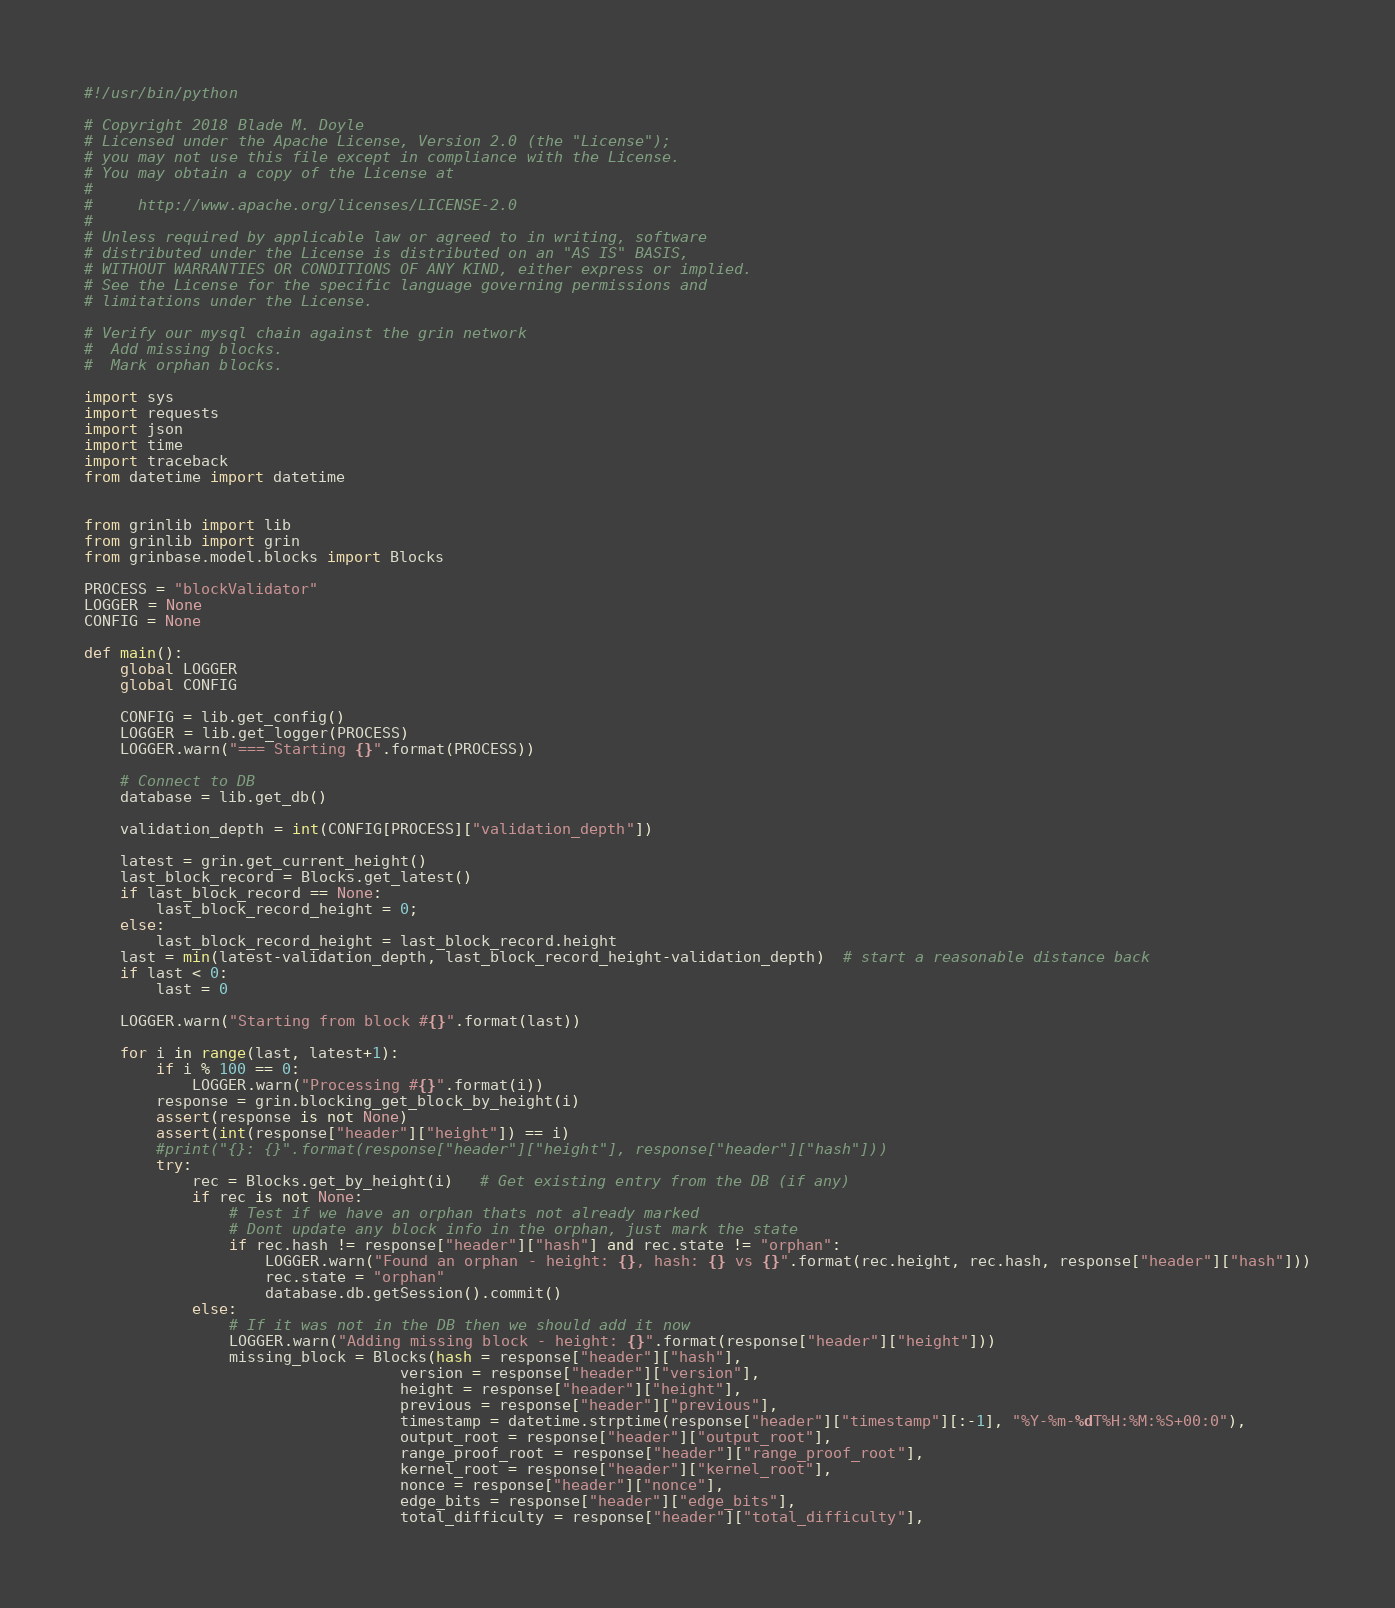<code> <loc_0><loc_0><loc_500><loc_500><_Python_>#!/usr/bin/python

# Copyright 2018 Blade M. Doyle
# Licensed under the Apache License, Version 2.0 (the "License");
# you may not use this file except in compliance with the License.
# You may obtain a copy of the License at
#
#     http://www.apache.org/licenses/LICENSE-2.0
#
# Unless required by applicable law or agreed to in writing, software
# distributed under the License is distributed on an "AS IS" BASIS,
# WITHOUT WARRANTIES OR CONDITIONS OF ANY KIND, either express or implied.
# See the License for the specific language governing permissions and
# limitations under the License.

# Verify our mysql chain against the grin network
#  Add missing blocks.
#  Mark orphan blocks.

import sys
import requests
import json
import time
import traceback
from datetime import datetime


from grinlib import lib
from grinlib import grin
from grinbase.model.blocks import Blocks

PROCESS = "blockValidator"
LOGGER = None
CONFIG = None

def main():
    global LOGGER
    global CONFIG

    CONFIG = lib.get_config()
    LOGGER = lib.get_logger(PROCESS)
    LOGGER.warn("=== Starting {}".format(PROCESS))
    
    # Connect to DB
    database = lib.get_db()

    validation_depth = int(CONFIG[PROCESS]["validation_depth"])

    latest = grin.get_current_height()
    last_block_record = Blocks.get_latest()
    if last_block_record == None:
        last_block_record_height = 0;
    else:
        last_block_record_height = last_block_record.height
    last = min(latest-validation_depth, last_block_record_height-validation_depth)  # start a reasonable distance back
    if last < 0:
        last = 0

    LOGGER.warn("Starting from block #{}".format(last))

    for i in range(last, latest+1):
        if i % 100 == 0:
            LOGGER.warn("Processing #{}".format(i))
        response = grin.blocking_get_block_by_height(i)
        assert(response is not None)
        assert(int(response["header"]["height"]) == i)
        #print("{}: {}".format(response["header"]["height"], response["header"]["hash"]))
        try:
            rec = Blocks.get_by_height(i)   # Get existing entry from the DB (if any)
            if rec is not None:
                # Test if we have an orphan thats not already marked
                # Dont update any block info in the orphan, just mark the state
                if rec.hash != response["header"]["hash"] and rec.state != "orphan":
                    LOGGER.warn("Found an orphan - height: {}, hash: {} vs {}".format(rec.height, rec.hash, response["header"]["hash"]))
                    rec.state = "orphan"
                    database.db.getSession().commit()
            else:
                # If it was not in the DB then we should add it now
                LOGGER.warn("Adding missing block - height: {}".format(response["header"]["height"]))
                missing_block = Blocks(hash = response["header"]["hash"],
                                   version = response["header"]["version"],
                                   height = response["header"]["height"],
                                   previous = response["header"]["previous"],
                                   timestamp = datetime.strptime(response["header"]["timestamp"][:-1], "%Y-%m-%dT%H:%M:%S+00:0"),
                                   output_root = response["header"]["output_root"],
                                   range_proof_root = response["header"]["range_proof_root"],
                                   kernel_root = response["header"]["kernel_root"],
                                   nonce = response["header"]["nonce"],
                                   edge_bits = response["header"]["edge_bits"],
                                   total_difficulty = response["header"]["total_difficulty"],</code> 